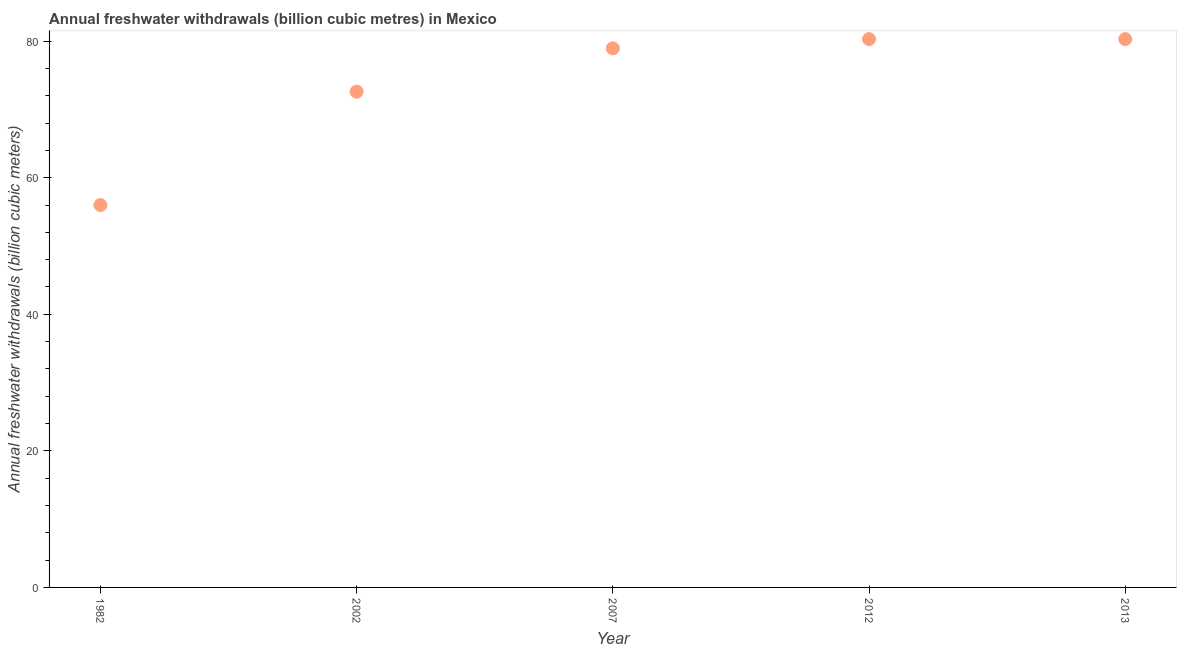What is the annual freshwater withdrawals in 2002?
Give a very brief answer. 72.6. Across all years, what is the maximum annual freshwater withdrawals?
Your answer should be very brief. 80.3. In which year was the annual freshwater withdrawals maximum?
Offer a very short reply. 2012. What is the sum of the annual freshwater withdrawals?
Keep it short and to the point. 368.15. What is the difference between the annual freshwater withdrawals in 1982 and 2013?
Provide a short and direct response. -24.3. What is the average annual freshwater withdrawals per year?
Your response must be concise. 73.63. What is the median annual freshwater withdrawals?
Your answer should be compact. 78.95. In how many years, is the annual freshwater withdrawals greater than 48 billion cubic meters?
Make the answer very short. 5. Do a majority of the years between 1982 and 2012 (inclusive) have annual freshwater withdrawals greater than 24 billion cubic meters?
Your answer should be compact. Yes. What is the ratio of the annual freshwater withdrawals in 2007 to that in 2013?
Keep it short and to the point. 0.98. Is the annual freshwater withdrawals in 1982 less than that in 2012?
Your answer should be very brief. Yes. Is the difference between the annual freshwater withdrawals in 1982 and 2013 greater than the difference between any two years?
Your response must be concise. Yes. What is the difference between the highest and the second highest annual freshwater withdrawals?
Give a very brief answer. 0. Is the sum of the annual freshwater withdrawals in 2002 and 2013 greater than the maximum annual freshwater withdrawals across all years?
Offer a terse response. Yes. What is the difference between the highest and the lowest annual freshwater withdrawals?
Your answer should be very brief. 24.3. In how many years, is the annual freshwater withdrawals greater than the average annual freshwater withdrawals taken over all years?
Your answer should be very brief. 3. How many years are there in the graph?
Your answer should be compact. 5. Are the values on the major ticks of Y-axis written in scientific E-notation?
Provide a succinct answer. No. Does the graph contain any zero values?
Give a very brief answer. No. What is the title of the graph?
Ensure brevity in your answer.  Annual freshwater withdrawals (billion cubic metres) in Mexico. What is the label or title of the Y-axis?
Ensure brevity in your answer.  Annual freshwater withdrawals (billion cubic meters). What is the Annual freshwater withdrawals (billion cubic meters) in 1982?
Provide a short and direct response. 56. What is the Annual freshwater withdrawals (billion cubic meters) in 2002?
Offer a very short reply. 72.6. What is the Annual freshwater withdrawals (billion cubic meters) in 2007?
Your answer should be compact. 78.95. What is the Annual freshwater withdrawals (billion cubic meters) in 2012?
Your response must be concise. 80.3. What is the Annual freshwater withdrawals (billion cubic meters) in 2013?
Offer a very short reply. 80.3. What is the difference between the Annual freshwater withdrawals (billion cubic meters) in 1982 and 2002?
Your answer should be compact. -16.6. What is the difference between the Annual freshwater withdrawals (billion cubic meters) in 1982 and 2007?
Provide a succinct answer. -22.95. What is the difference between the Annual freshwater withdrawals (billion cubic meters) in 1982 and 2012?
Your response must be concise. -24.3. What is the difference between the Annual freshwater withdrawals (billion cubic meters) in 1982 and 2013?
Your answer should be very brief. -24.3. What is the difference between the Annual freshwater withdrawals (billion cubic meters) in 2002 and 2007?
Your response must be concise. -6.35. What is the difference between the Annual freshwater withdrawals (billion cubic meters) in 2007 and 2012?
Your answer should be compact. -1.35. What is the difference between the Annual freshwater withdrawals (billion cubic meters) in 2007 and 2013?
Offer a terse response. -1.35. What is the ratio of the Annual freshwater withdrawals (billion cubic meters) in 1982 to that in 2002?
Provide a short and direct response. 0.77. What is the ratio of the Annual freshwater withdrawals (billion cubic meters) in 1982 to that in 2007?
Ensure brevity in your answer.  0.71. What is the ratio of the Annual freshwater withdrawals (billion cubic meters) in 1982 to that in 2012?
Ensure brevity in your answer.  0.7. What is the ratio of the Annual freshwater withdrawals (billion cubic meters) in 1982 to that in 2013?
Your response must be concise. 0.7. What is the ratio of the Annual freshwater withdrawals (billion cubic meters) in 2002 to that in 2007?
Your response must be concise. 0.92. What is the ratio of the Annual freshwater withdrawals (billion cubic meters) in 2002 to that in 2012?
Make the answer very short. 0.9. What is the ratio of the Annual freshwater withdrawals (billion cubic meters) in 2002 to that in 2013?
Give a very brief answer. 0.9. What is the ratio of the Annual freshwater withdrawals (billion cubic meters) in 2007 to that in 2012?
Offer a very short reply. 0.98. What is the ratio of the Annual freshwater withdrawals (billion cubic meters) in 2012 to that in 2013?
Your answer should be compact. 1. 